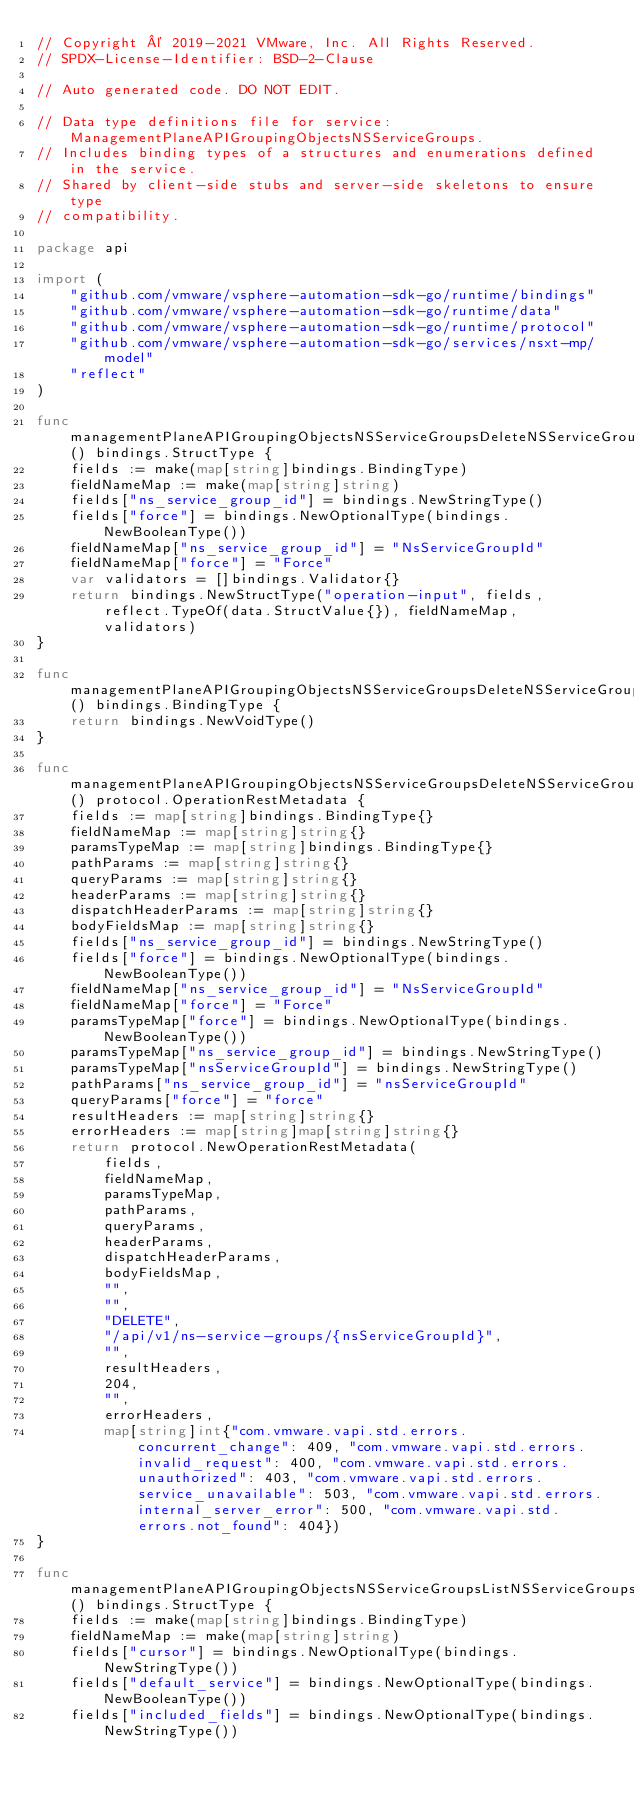<code> <loc_0><loc_0><loc_500><loc_500><_Go_>// Copyright © 2019-2021 VMware, Inc. All Rights Reserved.
// SPDX-License-Identifier: BSD-2-Clause

// Auto generated code. DO NOT EDIT.

// Data type definitions file for service: ManagementPlaneAPIGroupingObjectsNSServiceGroups.
// Includes binding types of a structures and enumerations defined in the service.
// Shared by client-side stubs and server-side skeletons to ensure type
// compatibility.

package api

import (
	"github.com/vmware/vsphere-automation-sdk-go/runtime/bindings"
	"github.com/vmware/vsphere-automation-sdk-go/runtime/data"
	"github.com/vmware/vsphere-automation-sdk-go/runtime/protocol"
	"github.com/vmware/vsphere-automation-sdk-go/services/nsxt-mp/model"
	"reflect"
)

func managementPlaneAPIGroupingObjectsNSServiceGroupsDeleteNSServiceGroupInputType() bindings.StructType {
	fields := make(map[string]bindings.BindingType)
	fieldNameMap := make(map[string]string)
	fields["ns_service_group_id"] = bindings.NewStringType()
	fields["force"] = bindings.NewOptionalType(bindings.NewBooleanType())
	fieldNameMap["ns_service_group_id"] = "NsServiceGroupId"
	fieldNameMap["force"] = "Force"
	var validators = []bindings.Validator{}
	return bindings.NewStructType("operation-input", fields, reflect.TypeOf(data.StructValue{}), fieldNameMap, validators)
}

func managementPlaneAPIGroupingObjectsNSServiceGroupsDeleteNSServiceGroupOutputType() bindings.BindingType {
	return bindings.NewVoidType()
}

func managementPlaneAPIGroupingObjectsNSServiceGroupsDeleteNSServiceGroupRestMetadata() protocol.OperationRestMetadata {
	fields := map[string]bindings.BindingType{}
	fieldNameMap := map[string]string{}
	paramsTypeMap := map[string]bindings.BindingType{}
	pathParams := map[string]string{}
	queryParams := map[string]string{}
	headerParams := map[string]string{}
	dispatchHeaderParams := map[string]string{}
	bodyFieldsMap := map[string]string{}
	fields["ns_service_group_id"] = bindings.NewStringType()
	fields["force"] = bindings.NewOptionalType(bindings.NewBooleanType())
	fieldNameMap["ns_service_group_id"] = "NsServiceGroupId"
	fieldNameMap["force"] = "Force"
	paramsTypeMap["force"] = bindings.NewOptionalType(bindings.NewBooleanType())
	paramsTypeMap["ns_service_group_id"] = bindings.NewStringType()
	paramsTypeMap["nsServiceGroupId"] = bindings.NewStringType()
	pathParams["ns_service_group_id"] = "nsServiceGroupId"
	queryParams["force"] = "force"
	resultHeaders := map[string]string{}
	errorHeaders := map[string]map[string]string{}
	return protocol.NewOperationRestMetadata(
		fields,
		fieldNameMap,
		paramsTypeMap,
		pathParams,
		queryParams,
		headerParams,
		dispatchHeaderParams,
		bodyFieldsMap,
		"",
		"",
		"DELETE",
		"/api/v1/ns-service-groups/{nsServiceGroupId}",
		"",
		resultHeaders,
		204,
		"",
		errorHeaders,
		map[string]int{"com.vmware.vapi.std.errors.concurrent_change": 409, "com.vmware.vapi.std.errors.invalid_request": 400, "com.vmware.vapi.std.errors.unauthorized": 403, "com.vmware.vapi.std.errors.service_unavailable": 503, "com.vmware.vapi.std.errors.internal_server_error": 500, "com.vmware.vapi.std.errors.not_found": 404})
}

func managementPlaneAPIGroupingObjectsNSServiceGroupsListNSServiceGroupsInputType() bindings.StructType {
	fields := make(map[string]bindings.BindingType)
	fieldNameMap := make(map[string]string)
	fields["cursor"] = bindings.NewOptionalType(bindings.NewStringType())
	fields["default_service"] = bindings.NewOptionalType(bindings.NewBooleanType())
	fields["included_fields"] = bindings.NewOptionalType(bindings.NewStringType())</code> 